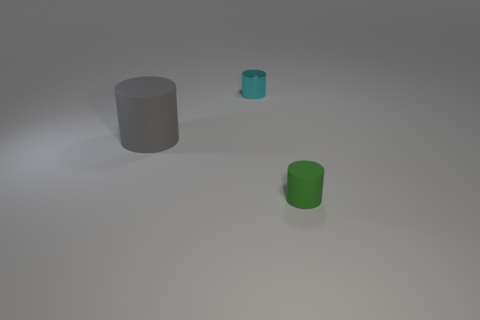Add 2 small blue things. How many objects exist? 5 Subtract all big gray cylinders. Subtract all rubber cylinders. How many objects are left? 0 Add 3 cyan cylinders. How many cyan cylinders are left? 4 Add 2 rubber objects. How many rubber objects exist? 4 Subtract 0 yellow cubes. How many objects are left? 3 